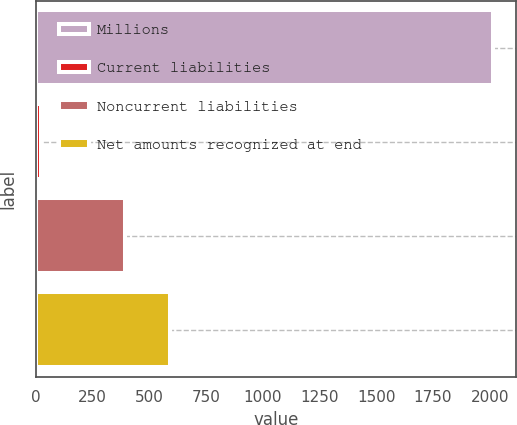<chart> <loc_0><loc_0><loc_500><loc_500><bar_chart><fcel>Millions<fcel>Current liabilities<fcel>Noncurrent liabilities<fcel>Net amounts recognized at end<nl><fcel>2015<fcel>22<fcel>393<fcel>592.3<nl></chart> 